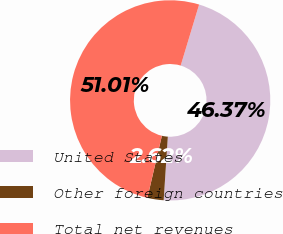<chart> <loc_0><loc_0><loc_500><loc_500><pie_chart><fcel>United States<fcel>Other foreign countries<fcel>Total net revenues<nl><fcel>46.37%<fcel>2.62%<fcel>51.01%<nl></chart> 